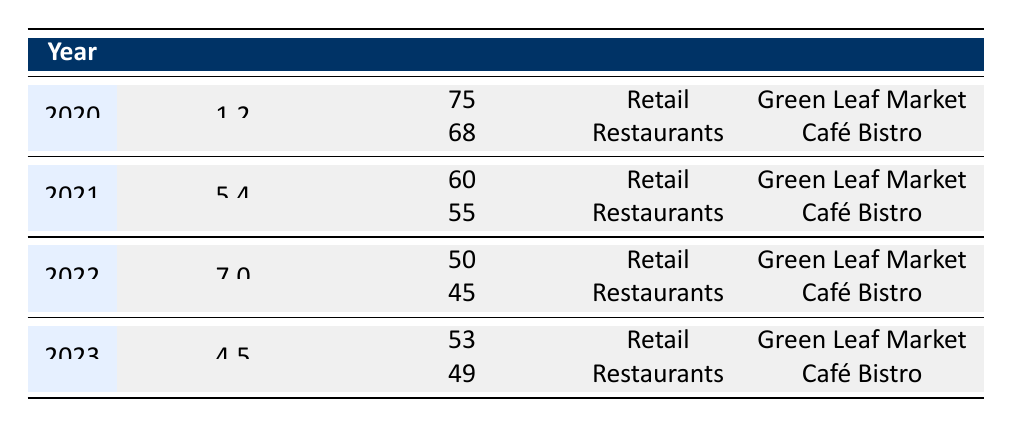What was the survival rate of the "Green Leaf Market" in 2022? In the table, for the year 2022, the survival rate for the "Green Leaf Market" in the Retail industry is listed under that year. Looking specifically at the row for 2022 and Retail, the survival rate is 50%.
Answer: 50 What was the highest recorded inflation rate in the table? By examining the inflation rates in the table, the highest value is in the year 2022, which is 7.0%. Other inflation rates are lower than this value.
Answer: 7.0 What is the survival rate for "Café Bistro" across the years available? The survival rates for "Café Bistro" can be found in the Restaurants section across all years. They are 68% (2020), 55% (2021), 45% (2022), and 49% (2023). Summing these rates gives a total of 217% over the four years.
Answer: 217 Did the survival rate for the "Green Leaf Market" decrease every year? Looking at the annual survival rates for "Green Leaf Market": 75% in 2020, 60% in 2021, 50% in 2022, and 53% in 2023. It shows a decrease from 2020 to 2022, but a slight increase in 2023. Hence, the statement is false.
Answer: No What was the difference in survival rates between "Café Bistro" and "Green Leaf Market" in 2021? For the year 2021, the survival rate for "Café Bistro" was 55% and for "Green Leaf Market," it was 60%. The difference can be calculated by subtracting the survival rate of "Café Bistro" from that of "Green Leaf Market": 60% - 55% = 5%.
Answer: 5% What was the average survival rate for the Retail industry from 2020 to 2023? The survival rates for the Retail industry are 75% (2020), 60% (2021), 50% (2022), and 53% (2023). To find the average, sum these rates: 75 + 60 + 50 + 53 = 238%. There are four data points, so the average is 238% / 4 = 59.5%.
Answer: 59.5 Was the inflation rate in 2023 higher than in 2021? The inflation rates listed show 5.4% for 2021 and 4.5% for 2023. Since 4.5% is lower than 5.4%, the statement is false.
Answer: No What is the survival rate for both industries in 2022 combined? In 2022, the survival rates are 50% for "Green Leaf Market" and 45% for "Café Bistro". Combined, this would be 50% + 45% = 95%.
Answer: 95 